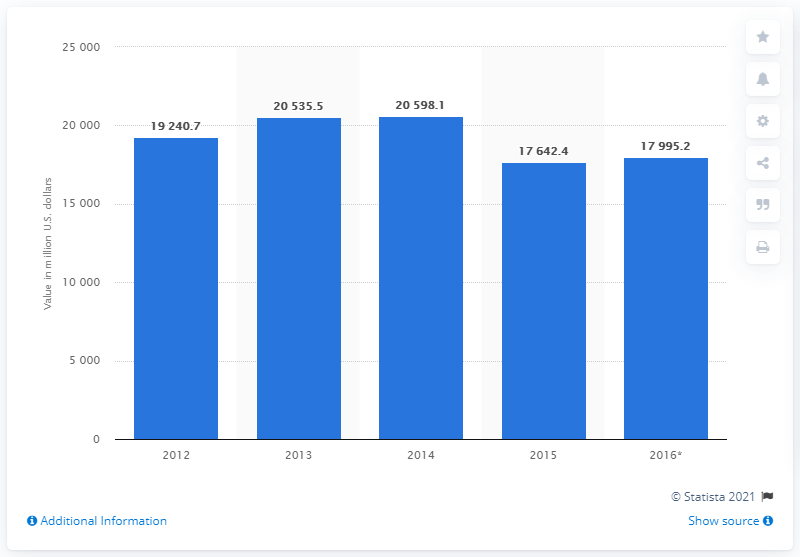Indicate a few pertinent items in this graphic. According to estimates, Austria spent approximately 20,598.1 euros on food in 2014. 